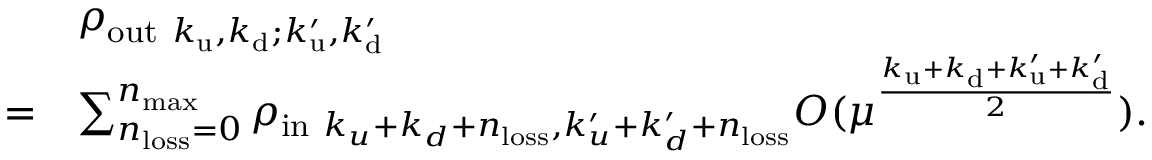Convert formula to latex. <formula><loc_0><loc_0><loc_500><loc_500>\begin{array} { r l } & { \rho _ { o u t k _ { u } , k _ { d } ; k _ { u } ^ { \prime } , k _ { d } ^ { \prime } } } \\ { = } & { \sum _ { n _ { l o s s } = 0 } ^ { n _ { \max } } \rho _ { i n k _ { u } + k _ { d } + n _ { l o s s } , k _ { u } ^ { \prime } + k _ { d } ^ { \prime } + n _ { l o s s } } O ( \mu ^ { \frac { k _ { u } + k _ { d } + k _ { u } ^ { \prime } + k _ { d } ^ { \prime } } { 2 } } ) . } \end{array}</formula> 